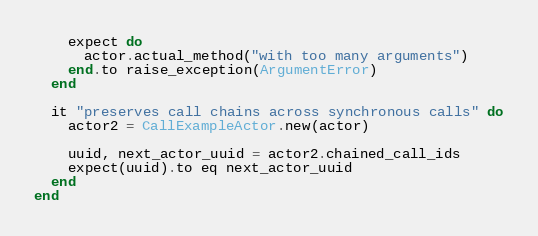Convert code to text. <code><loc_0><loc_0><loc_500><loc_500><_Ruby_>    expect do
      actor.actual_method("with too many arguments")
    end.to raise_exception(ArgumentError)
  end

  it "preserves call chains across synchronous calls" do
    actor2 = CallExampleActor.new(actor)

    uuid, next_actor_uuid = actor2.chained_call_ids
    expect(uuid).to eq next_actor_uuid
  end
end
</code> 